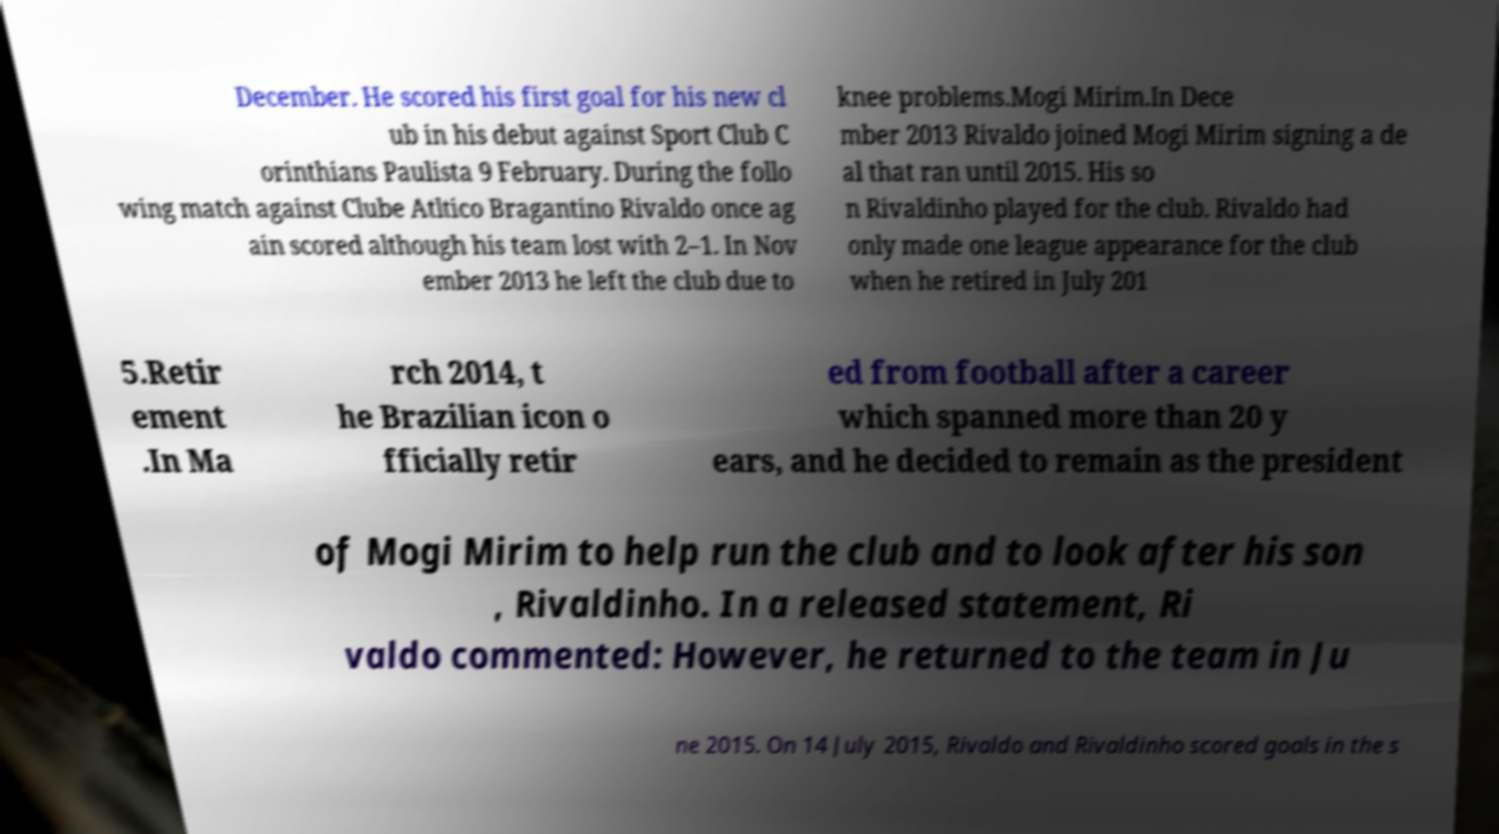Could you extract and type out the text from this image? December. He scored his first goal for his new cl ub in his debut against Sport Club C orinthians Paulista 9 February. During the follo wing match against Clube Atltico Bragantino Rivaldo once ag ain scored although his team lost with 2–1. In Nov ember 2013 he left the club due to knee problems.Mogi Mirim.In Dece mber 2013 Rivaldo joined Mogi Mirim signing a de al that ran until 2015. His so n Rivaldinho played for the club. Rivaldo had only made one league appearance for the club when he retired in July 201 5.Retir ement .In Ma rch 2014, t he Brazilian icon o fficially retir ed from football after a career which spanned more than 20 y ears, and he decided to remain as the president of Mogi Mirim to help run the club and to look after his son , Rivaldinho. In a released statement, Ri valdo commented: However, he returned to the team in Ju ne 2015. On 14 July 2015, Rivaldo and Rivaldinho scored goals in the s 